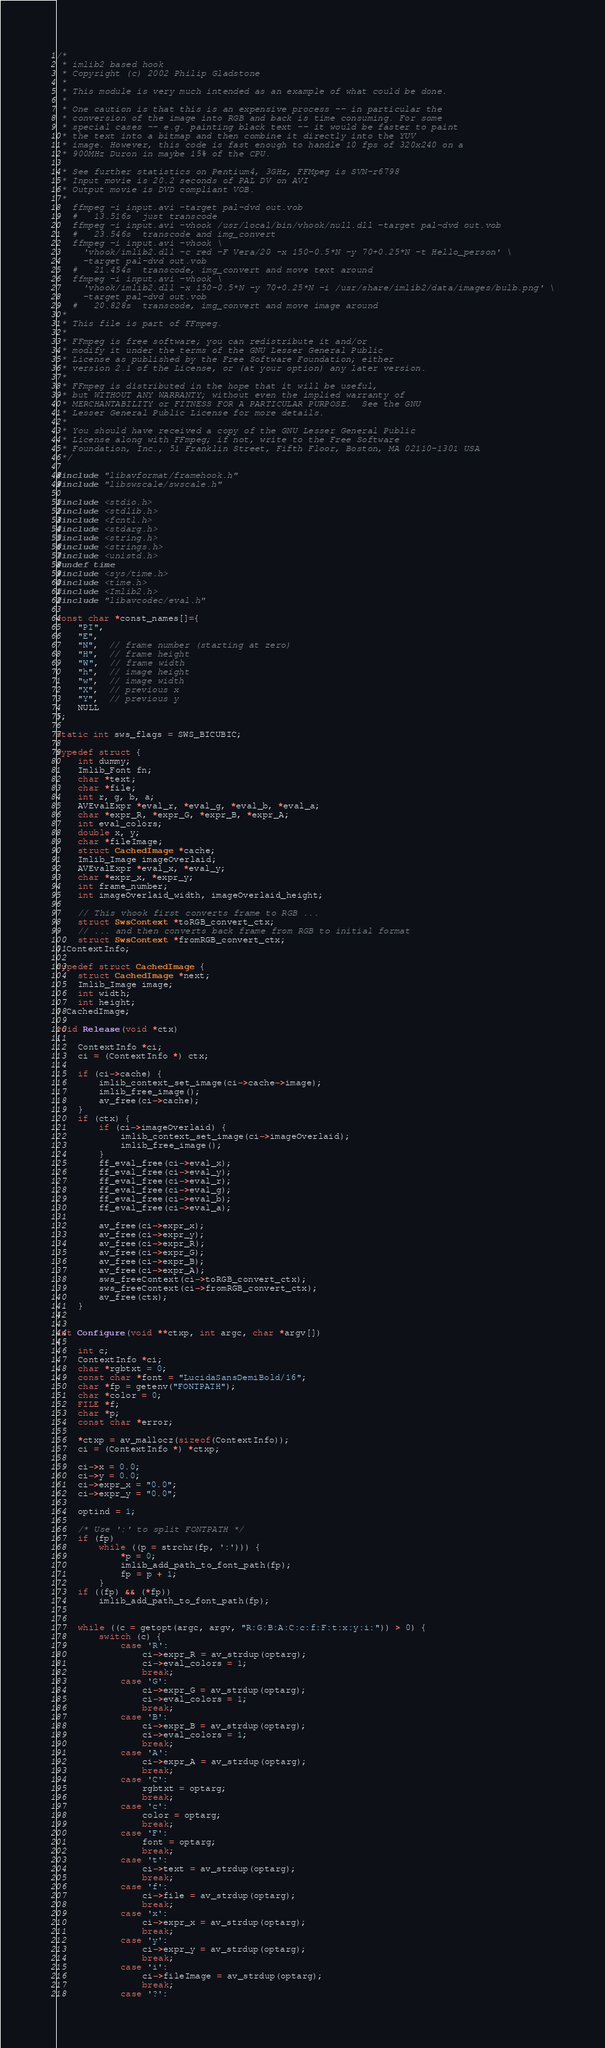<code> <loc_0><loc_0><loc_500><loc_500><_C_>/*
 * imlib2 based hook
 * Copyright (c) 2002 Philip Gladstone
 *
 * This module is very much intended as an example of what could be done.
 *
 * One caution is that this is an expensive process -- in particular the
 * conversion of the image into RGB and back is time consuming. For some
 * special cases -- e.g. painting black text -- it would be faster to paint
 * the text into a bitmap and then combine it directly into the YUV
 * image. However, this code is fast enough to handle 10 fps of 320x240 on a
 * 900MHz Duron in maybe 15% of the CPU.

 * See further statistics on Pentium4, 3GHz, FFMpeg is SVN-r6798
 * Input movie is 20.2 seconds of PAL DV on AVI
 * Output movie is DVD compliant VOB.
 *
   ffmpeg -i input.avi -target pal-dvd out.vob
   #   13.516s  just transcode
   ffmpeg -i input.avi -vhook /usr/local/bin/vhook/null.dll -target pal-dvd out.vob
   #   23.546s  transcode and img_convert
   ffmpeg -i input.avi -vhook \
     'vhook/imlib2.dll -c red -F Vera/20 -x 150-0.5*N -y 70+0.25*N -t Hello_person' \
     -target pal-dvd out.vob
   #   21.454s  transcode, img_convert and move text around
   ffmpeg -i input.avi -vhook \
     'vhook/imlib2.dll -x 150-0.5*N -y 70+0.25*N -i /usr/share/imlib2/data/images/bulb.png' \
     -target pal-dvd out.vob
   #   20.828s  transcode, img_convert and move image around
 *
 * This file is part of FFmpeg.
 *
 * FFmpeg is free software; you can redistribute it and/or
 * modify it under the terms of the GNU Lesser General Public
 * License as published by the Free Software Foundation; either
 * version 2.1 of the License, or (at your option) any later version.
 *
 * FFmpeg is distributed in the hope that it will be useful,
 * but WITHOUT ANY WARRANTY; without even the implied warranty of
 * MERCHANTABILITY or FITNESS FOR A PARTICULAR PURPOSE.  See the GNU
 * Lesser General Public License for more details.
 *
 * You should have received a copy of the GNU Lesser General Public
 * License along with FFmpeg; if not, write to the Free Software
 * Foundation, Inc., 51 Franklin Street, Fifth Floor, Boston, MA 02110-1301 USA
 */

#include "libavformat/framehook.h"
#include "libswscale/swscale.h"

#include <stdio.h>
#include <stdlib.h>
#include <fcntl.h>
#include <stdarg.h>
#include <string.h>
#include <strings.h>
#include <unistd.h>
#undef time
#include <sys/time.h>
#include <time.h>
#include <Imlib2.h>
#include "libavcodec/eval.h"

const char *const_names[]={
    "PI",
    "E",
    "N",  // frame number (starting at zero)
    "H",  // frame height
    "W",  // frame width
    "h",  // image height
    "w",  // image width
    "X",  // previous x
    "Y",  // previous y
    NULL
};

static int sws_flags = SWS_BICUBIC;

typedef struct {
    int dummy;
    Imlib_Font fn;
    char *text;
    char *file;
    int r, g, b, a;
    AVEvalExpr *eval_r, *eval_g, *eval_b, *eval_a;
    char *expr_R, *expr_G, *expr_B, *expr_A;
    int eval_colors;
    double x, y;
    char *fileImage;
    struct CachedImage *cache;
    Imlib_Image imageOverlaid;
    AVEvalExpr *eval_x, *eval_y;
    char *expr_x, *expr_y;
    int frame_number;
    int imageOverlaid_width, imageOverlaid_height;

    // This vhook first converts frame to RGB ...
    struct SwsContext *toRGB_convert_ctx;
    // ... and then converts back frame from RGB to initial format
    struct SwsContext *fromRGB_convert_ctx;
} ContextInfo;

typedef struct CachedImage {
    struct CachedImage *next;
    Imlib_Image image;
    int width;
    int height;
} CachedImage;

void Release(void *ctx)
{
    ContextInfo *ci;
    ci = (ContextInfo *) ctx;

    if (ci->cache) {
        imlib_context_set_image(ci->cache->image);
        imlib_free_image();
        av_free(ci->cache);
    }
    if (ctx) {
        if (ci->imageOverlaid) {
            imlib_context_set_image(ci->imageOverlaid);
            imlib_free_image();
        }
        ff_eval_free(ci->eval_x);
        ff_eval_free(ci->eval_y);
        ff_eval_free(ci->eval_r);
        ff_eval_free(ci->eval_g);
        ff_eval_free(ci->eval_b);
        ff_eval_free(ci->eval_a);

        av_free(ci->expr_x);
        av_free(ci->expr_y);
        av_free(ci->expr_R);
        av_free(ci->expr_G);
        av_free(ci->expr_B);
        av_free(ci->expr_A);
        sws_freeContext(ci->toRGB_convert_ctx);
        sws_freeContext(ci->fromRGB_convert_ctx);
        av_free(ctx);
    }
}

int Configure(void **ctxp, int argc, char *argv[])
{
    int c;
    ContextInfo *ci;
    char *rgbtxt = 0;
    const char *font = "LucidaSansDemiBold/16";
    char *fp = getenv("FONTPATH");
    char *color = 0;
    FILE *f;
    char *p;
    const char *error;

    *ctxp = av_mallocz(sizeof(ContextInfo));
    ci = (ContextInfo *) *ctxp;

    ci->x = 0.0;
    ci->y = 0.0;
    ci->expr_x = "0.0";
    ci->expr_y = "0.0";

    optind = 1;

    /* Use ':' to split FONTPATH */
    if (fp)
        while ((p = strchr(fp, ':'))) {
            *p = 0;
            imlib_add_path_to_font_path(fp);
            fp = p + 1;
        }
    if ((fp) && (*fp))
        imlib_add_path_to_font_path(fp);


    while ((c = getopt(argc, argv, "R:G:B:A:C:c:f:F:t:x:y:i:")) > 0) {
        switch (c) {
            case 'R':
                ci->expr_R = av_strdup(optarg);
                ci->eval_colors = 1;
                break;
            case 'G':
                ci->expr_G = av_strdup(optarg);
                ci->eval_colors = 1;
                break;
            case 'B':
                ci->expr_B = av_strdup(optarg);
                ci->eval_colors = 1;
                break;
            case 'A':
                ci->expr_A = av_strdup(optarg);
                break;
            case 'C':
                rgbtxt = optarg;
                break;
            case 'c':
                color = optarg;
                break;
            case 'F':
                font = optarg;
                break;
            case 't':
                ci->text = av_strdup(optarg);
                break;
            case 'f':
                ci->file = av_strdup(optarg);
                break;
            case 'x':
                ci->expr_x = av_strdup(optarg);
                break;
            case 'y':
                ci->expr_y = av_strdup(optarg);
                break;
            case 'i':
                ci->fileImage = av_strdup(optarg);
                break;
            case '?':</code> 